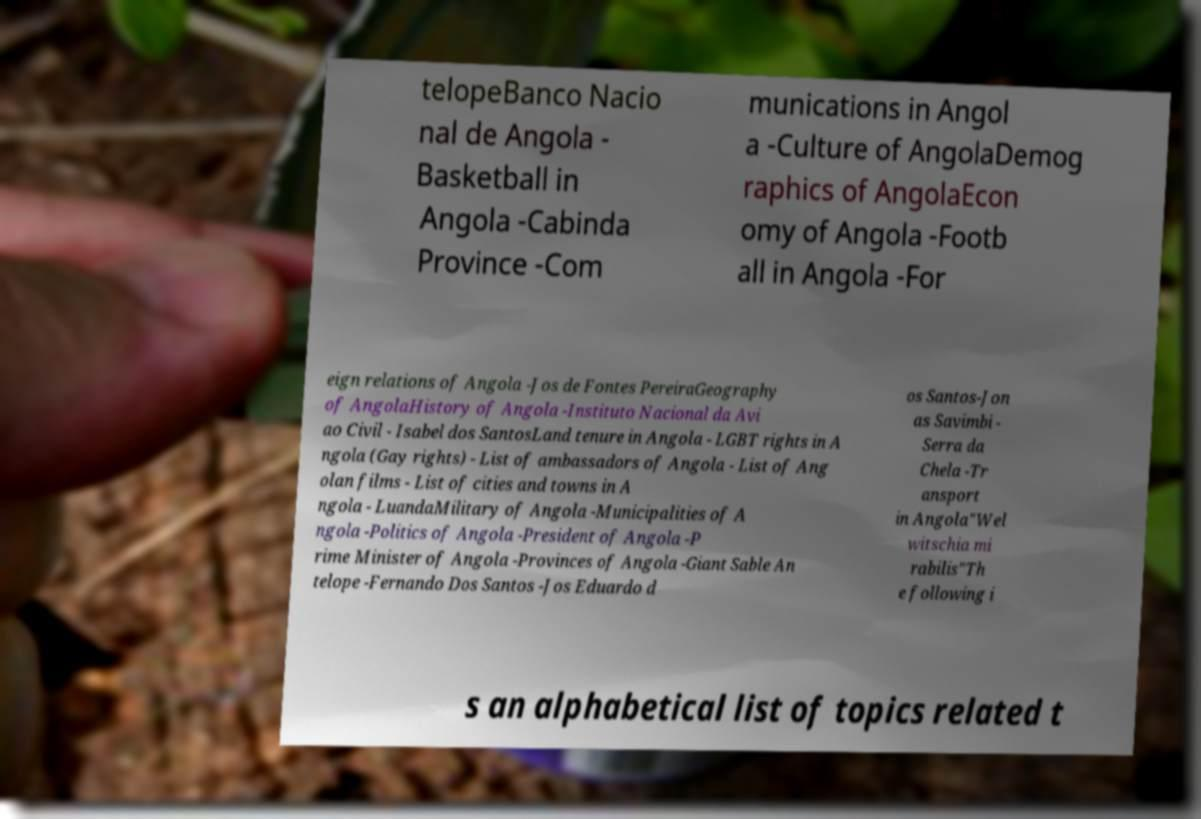What messages or text are displayed in this image? I need them in a readable, typed format. telopeBanco Nacio nal de Angola - Basketball in Angola -Cabinda Province -Com munications in Angol a -Culture of AngolaDemog raphics of AngolaEcon omy of Angola -Footb all in Angola -For eign relations of Angola -Jos de Fontes PereiraGeography of AngolaHistory of Angola -Instituto Nacional da Avi ao Civil - Isabel dos SantosLand tenure in Angola - LGBT rights in A ngola (Gay rights) - List of ambassadors of Angola - List of Ang olan films - List of cities and towns in A ngola - LuandaMilitary of Angola -Municipalities of A ngola -Politics of Angola -President of Angola -P rime Minister of Angola -Provinces of Angola -Giant Sable An telope -Fernando Dos Santos -Jos Eduardo d os Santos-Jon as Savimbi - Serra da Chela -Tr ansport in Angola"Wel witschia mi rabilis"Th e following i s an alphabetical list of topics related t 